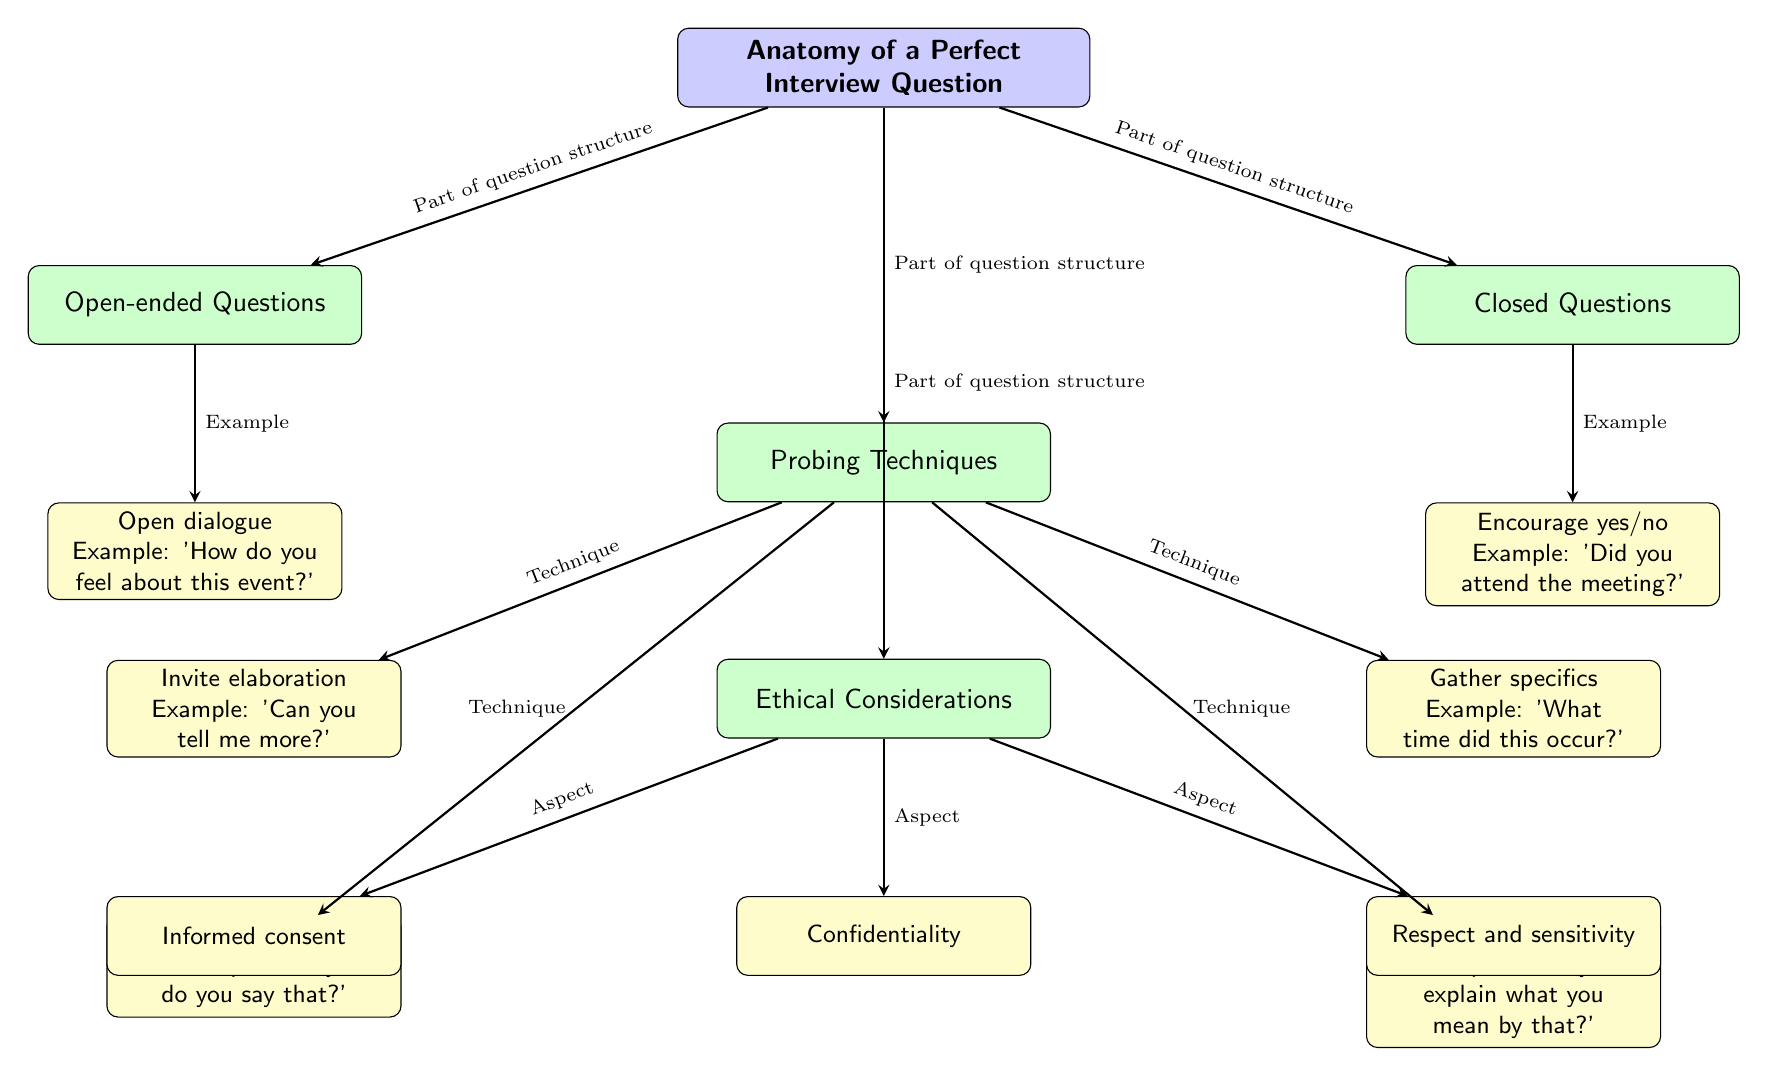What are the main components of the diagram? The main components of the diagram are the sections labeled as Open-ended Questions, Closed Questions, Probing Techniques, and Ethical Considerations, each of which represents an essential aspect of crafting perfect interview questions.
Answer: Open-ended Questions, Closed Questions, Probing Techniques, Ethical Considerations How many examples are provided under Probing Techniques? The Probing Techniques section includes four examples illustrated by the nodes, which describe different techniques for probing in interviews. These are Invite elaboration, Gather specifics, Follow-up questions, and Clarification.
Answer: Four What type of question is described by the example 'Did you attend the meeting?' This example is categorized under Closed Questions, as it prompts the respondent to answer with a simple yes or no, limiting the depth of response.
Answer: Closed Questions What ethical aspect relates to the process of collecting interview data? The diagram outlines Informed consent as a critical ethical aspect, which refers to ensuring that interviewees are fully aware of what participating entails and agreeing to it.
Answer: Informed consent Which probing technique invites elaboration from the interviewee? The technique labeled 'Invite elaboration' specifically refers to asking questions like 'Can you tell me more?' which encourages the interviewee to expand on their thoughts and provide more information.
Answer: Invite elaboration What is one example of an open-ended question shown in the diagram? The diagram provides 'How do you feel about this event?' as an example of an open-ended question, allowing for a more detailed and expressive response from the interviewee.
Answer: How do you feel about this event? What types of considerations does the Ethical Considerations section include? The Ethical Considerations section highlights three aspects: Informed consent, Confidentiality, and Respect and sensitivity, underlining the importance of ethical practices when conducting interviews.
Answer: Informed consent, Confidentiality, Respect and sensitivity How are Open-ended Questions and Closed Questions categorized in relation to the main node? Both Open-ended Questions and Closed Questions are directly linked to the main node, indicating that they are fundamental parts of the question structure necessary for interviews.
Answer: Part of question structure 